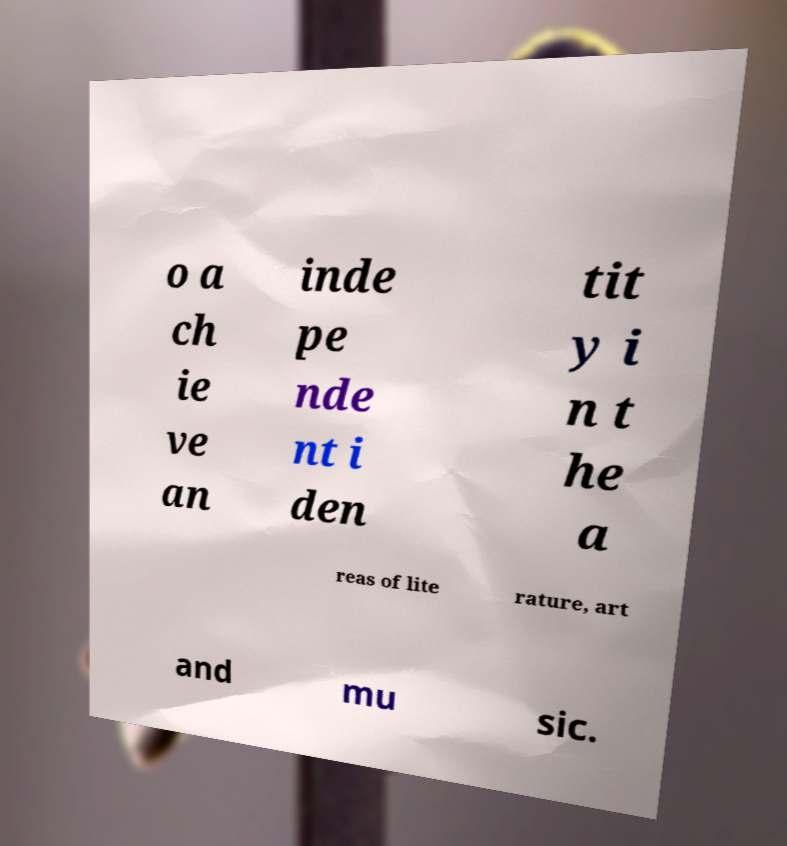Could you extract and type out the text from this image? o a ch ie ve an inde pe nde nt i den tit y i n t he a reas of lite rature, art and mu sic. 